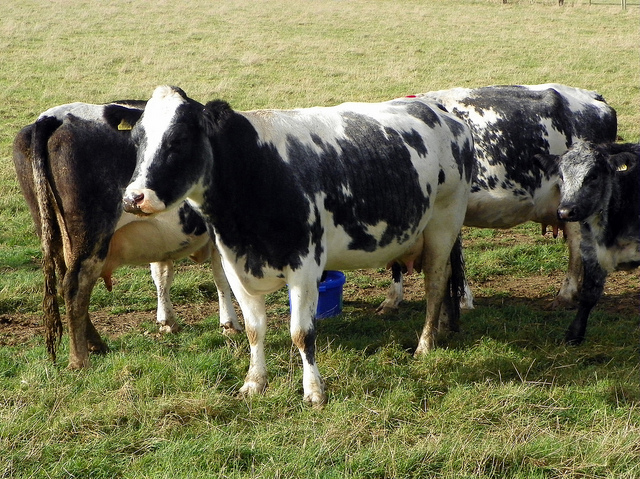Can you tell something about the cow's environment or living conditions? The cows are in a pasture with ample green grass, indicating a natural and likely free-range environment, which is often associated with better animal welfare and quality of life for the livestock. 